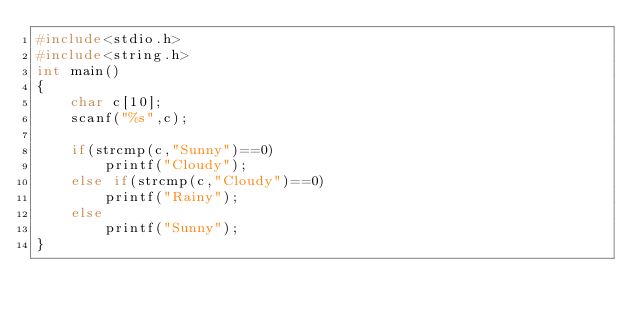<code> <loc_0><loc_0><loc_500><loc_500><_C_>#include<stdio.h>
#include<string.h>
int main()
{
    char c[10];
    scanf("%s",c);

    if(strcmp(c,"Sunny")==0)
        printf("Cloudy");
    else if(strcmp(c,"Cloudy")==0)
        printf("Rainy");
    else
        printf("Sunny");
}
</code> 